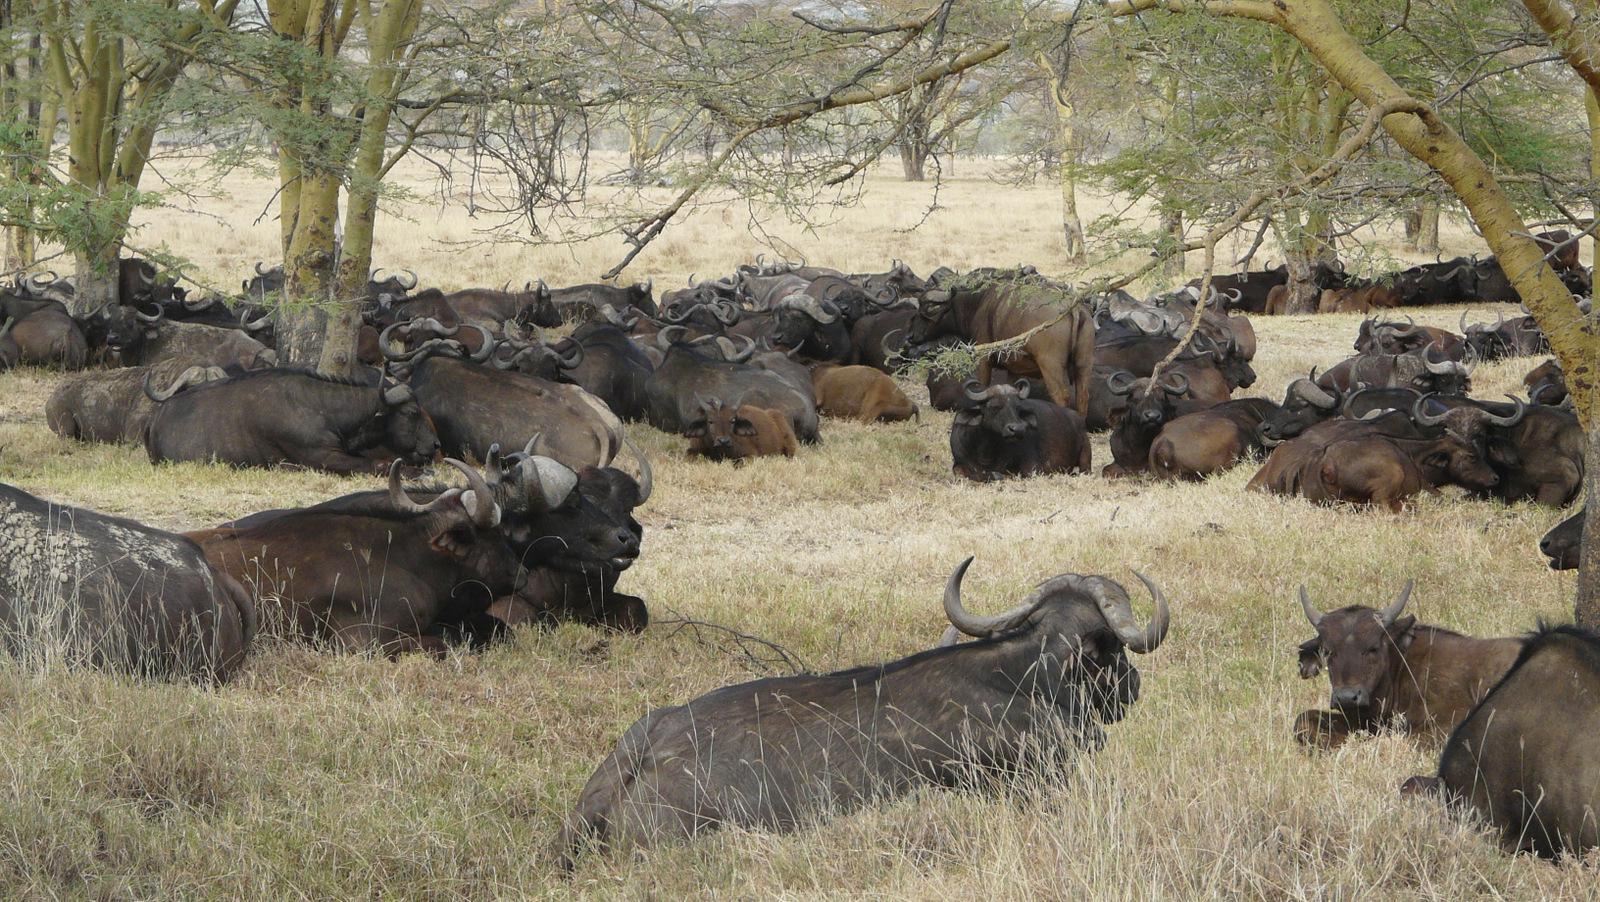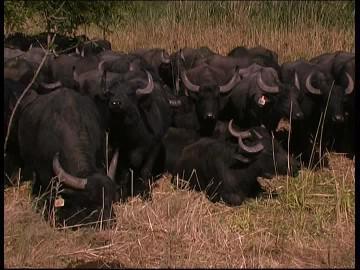The first image is the image on the left, the second image is the image on the right. Considering the images on both sides, is "water buffalo are at the water hole" valid? Answer yes or no. No. The first image is the image on the left, the second image is the image on the right. Considering the images on both sides, is "There are no more than six water buffaloes in the left image." valid? Answer yes or no. No. 